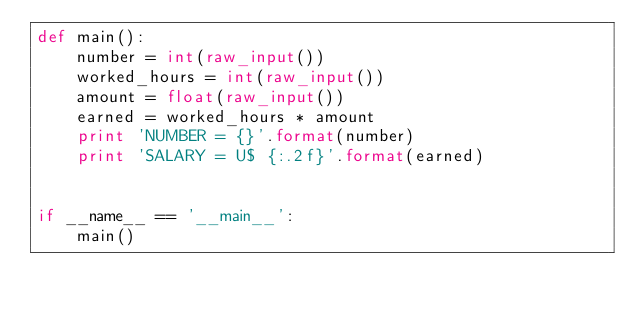Convert code to text. <code><loc_0><loc_0><loc_500><loc_500><_Python_>def main():
    number = int(raw_input())
    worked_hours = int(raw_input())
    amount = float(raw_input())
    earned = worked_hours * amount
    print 'NUMBER = {}'.format(number)
    print 'SALARY = U$ {:.2f}'.format(earned)


if __name__ == '__main__':
    main()
</code> 